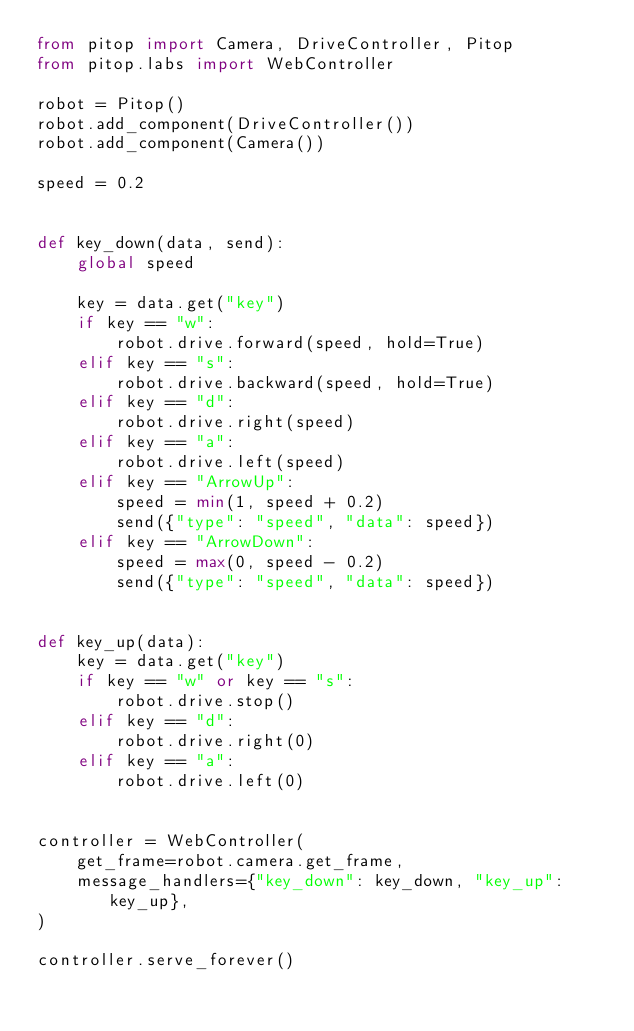Convert code to text. <code><loc_0><loc_0><loc_500><loc_500><_Python_>from pitop import Camera, DriveController, Pitop
from pitop.labs import WebController

robot = Pitop()
robot.add_component(DriveController())
robot.add_component(Camera())

speed = 0.2


def key_down(data, send):
    global speed

    key = data.get("key")
    if key == "w":
        robot.drive.forward(speed, hold=True)
    elif key == "s":
        robot.drive.backward(speed, hold=True)
    elif key == "d":
        robot.drive.right(speed)
    elif key == "a":
        robot.drive.left(speed)
    elif key == "ArrowUp":
        speed = min(1, speed + 0.2)
        send({"type": "speed", "data": speed})
    elif key == "ArrowDown":
        speed = max(0, speed - 0.2)
        send({"type": "speed", "data": speed})


def key_up(data):
    key = data.get("key")
    if key == "w" or key == "s":
        robot.drive.stop()
    elif key == "d":
        robot.drive.right(0)
    elif key == "a":
        robot.drive.left(0)


controller = WebController(
    get_frame=robot.camera.get_frame,
    message_handlers={"key_down": key_down, "key_up": key_up},
)

controller.serve_forever()
</code> 